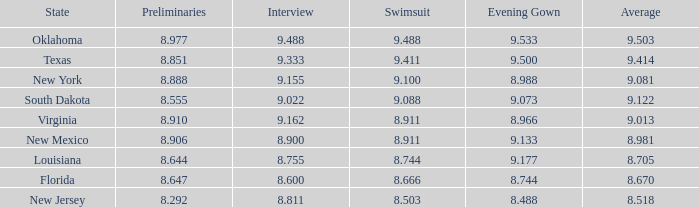 what's the evening gown where state is south dakota 9.073. Would you mind parsing the complete table? {'header': ['State', 'Preliminaries', 'Interview', 'Swimsuit', 'Evening Gown', 'Average'], 'rows': [['Oklahoma', '8.977', '9.488', '9.488', '9.533', '9.503'], ['Texas', '8.851', '9.333', '9.411', '9.500', '9.414'], ['New York', '8.888', '9.155', '9.100', '8.988', '9.081'], ['South Dakota', '8.555', '9.022', '9.088', '9.073', '9.122'], ['Virginia', '8.910', '9.162', '8.911', '8.966', '9.013'], ['New Mexico', '8.906', '8.900', '8.911', '9.133', '8.981'], ['Louisiana', '8.644', '8.755', '8.744', '9.177', '8.705'], ['Florida', '8.647', '8.600', '8.666', '8.744', '8.670'], ['New Jersey', '8.292', '8.811', '8.503', '8.488', '8.518']]} 